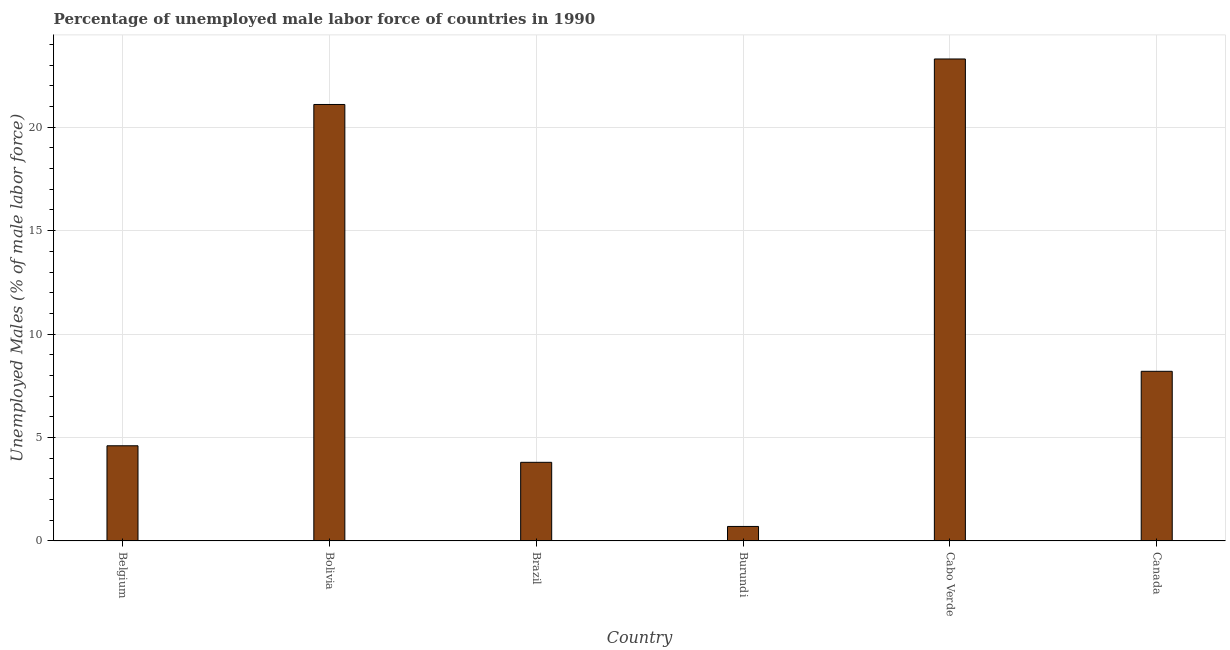Does the graph contain any zero values?
Offer a very short reply. No. Does the graph contain grids?
Make the answer very short. Yes. What is the title of the graph?
Make the answer very short. Percentage of unemployed male labor force of countries in 1990. What is the label or title of the Y-axis?
Offer a very short reply. Unemployed Males (% of male labor force). What is the total unemployed male labour force in Cabo Verde?
Make the answer very short. 23.3. Across all countries, what is the maximum total unemployed male labour force?
Ensure brevity in your answer.  23.3. Across all countries, what is the minimum total unemployed male labour force?
Make the answer very short. 0.7. In which country was the total unemployed male labour force maximum?
Offer a very short reply. Cabo Verde. In which country was the total unemployed male labour force minimum?
Make the answer very short. Burundi. What is the sum of the total unemployed male labour force?
Provide a short and direct response. 61.7. What is the difference between the total unemployed male labour force in Bolivia and Burundi?
Give a very brief answer. 20.4. What is the average total unemployed male labour force per country?
Your answer should be compact. 10.28. What is the median total unemployed male labour force?
Give a very brief answer. 6.4. What is the ratio of the total unemployed male labour force in Belgium to that in Canada?
Give a very brief answer. 0.56. What is the difference between the highest and the lowest total unemployed male labour force?
Make the answer very short. 22.6. How many bars are there?
Provide a succinct answer. 6. How many countries are there in the graph?
Ensure brevity in your answer.  6. What is the Unemployed Males (% of male labor force) of Belgium?
Your response must be concise. 4.6. What is the Unemployed Males (% of male labor force) of Bolivia?
Ensure brevity in your answer.  21.1. What is the Unemployed Males (% of male labor force) in Brazil?
Offer a very short reply. 3.8. What is the Unemployed Males (% of male labor force) in Burundi?
Provide a succinct answer. 0.7. What is the Unemployed Males (% of male labor force) in Cabo Verde?
Your answer should be compact. 23.3. What is the Unemployed Males (% of male labor force) in Canada?
Your response must be concise. 8.2. What is the difference between the Unemployed Males (% of male labor force) in Belgium and Bolivia?
Offer a terse response. -16.5. What is the difference between the Unemployed Males (% of male labor force) in Belgium and Burundi?
Make the answer very short. 3.9. What is the difference between the Unemployed Males (% of male labor force) in Belgium and Cabo Verde?
Your answer should be compact. -18.7. What is the difference between the Unemployed Males (% of male labor force) in Bolivia and Burundi?
Offer a very short reply. 20.4. What is the difference between the Unemployed Males (% of male labor force) in Bolivia and Cabo Verde?
Your answer should be very brief. -2.2. What is the difference between the Unemployed Males (% of male labor force) in Brazil and Cabo Verde?
Make the answer very short. -19.5. What is the difference between the Unemployed Males (% of male labor force) in Burundi and Cabo Verde?
Provide a succinct answer. -22.6. What is the ratio of the Unemployed Males (% of male labor force) in Belgium to that in Bolivia?
Give a very brief answer. 0.22. What is the ratio of the Unemployed Males (% of male labor force) in Belgium to that in Brazil?
Make the answer very short. 1.21. What is the ratio of the Unemployed Males (% of male labor force) in Belgium to that in Burundi?
Your answer should be compact. 6.57. What is the ratio of the Unemployed Males (% of male labor force) in Belgium to that in Cabo Verde?
Make the answer very short. 0.2. What is the ratio of the Unemployed Males (% of male labor force) in Belgium to that in Canada?
Keep it short and to the point. 0.56. What is the ratio of the Unemployed Males (% of male labor force) in Bolivia to that in Brazil?
Make the answer very short. 5.55. What is the ratio of the Unemployed Males (% of male labor force) in Bolivia to that in Burundi?
Offer a very short reply. 30.14. What is the ratio of the Unemployed Males (% of male labor force) in Bolivia to that in Cabo Verde?
Keep it short and to the point. 0.91. What is the ratio of the Unemployed Males (% of male labor force) in Bolivia to that in Canada?
Provide a succinct answer. 2.57. What is the ratio of the Unemployed Males (% of male labor force) in Brazil to that in Burundi?
Make the answer very short. 5.43. What is the ratio of the Unemployed Males (% of male labor force) in Brazil to that in Cabo Verde?
Keep it short and to the point. 0.16. What is the ratio of the Unemployed Males (% of male labor force) in Brazil to that in Canada?
Give a very brief answer. 0.46. What is the ratio of the Unemployed Males (% of male labor force) in Burundi to that in Cabo Verde?
Keep it short and to the point. 0.03. What is the ratio of the Unemployed Males (% of male labor force) in Burundi to that in Canada?
Ensure brevity in your answer.  0.09. What is the ratio of the Unemployed Males (% of male labor force) in Cabo Verde to that in Canada?
Your answer should be very brief. 2.84. 